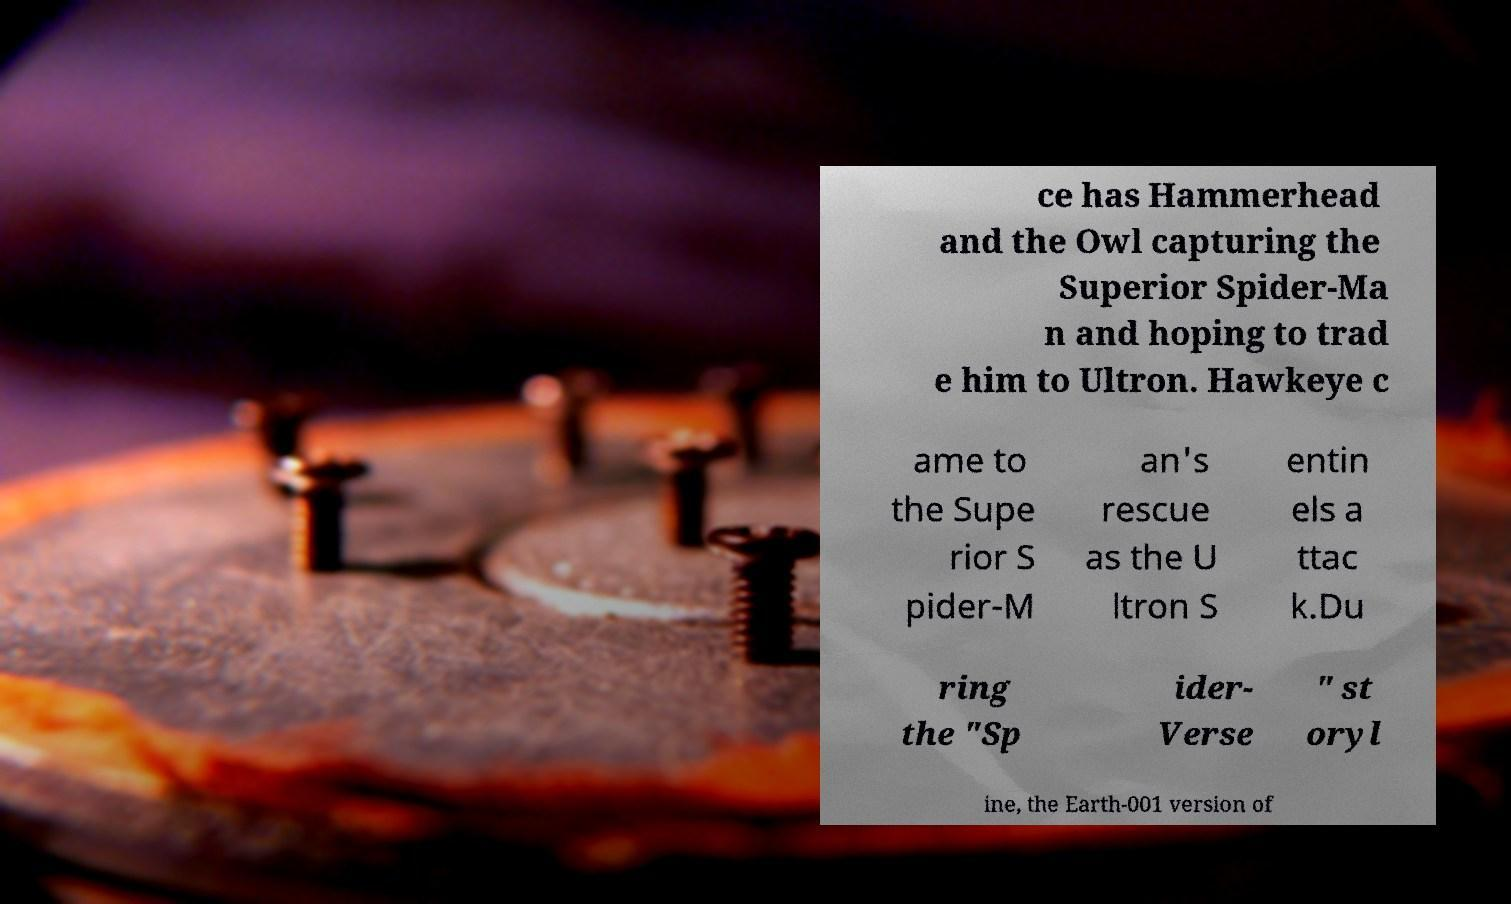Could you assist in decoding the text presented in this image and type it out clearly? ce has Hammerhead and the Owl capturing the Superior Spider-Ma n and hoping to trad e him to Ultron. Hawkeye c ame to the Supe rior S pider-M an's rescue as the U ltron S entin els a ttac k.Du ring the "Sp ider- Verse " st oryl ine, the Earth-001 version of 